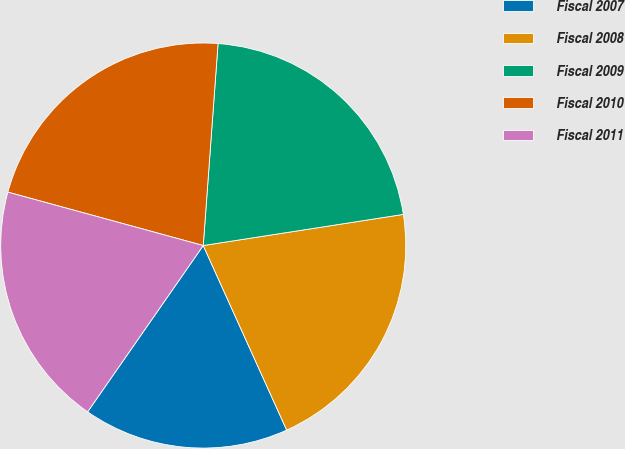<chart> <loc_0><loc_0><loc_500><loc_500><pie_chart><fcel>Fiscal 2007<fcel>Fiscal 2008<fcel>Fiscal 2009<fcel>Fiscal 2010<fcel>Fiscal 2011<nl><fcel>16.43%<fcel>20.7%<fcel>21.38%<fcel>21.92%<fcel>19.58%<nl></chart> 